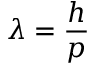<formula> <loc_0><loc_0><loc_500><loc_500>\lambda = { \frac { h } { p } }</formula> 